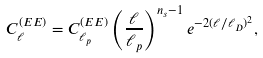Convert formula to latex. <formula><loc_0><loc_0><loc_500><loc_500>C _ { \ell } ^ { ( E E ) } = C _ { \ell _ { p } } ^ { ( E E ) } \left ( \frac { \ell } { \ell _ { p } } \right ) ^ { n _ { s } - 1 } e ^ { - 2 ( \ell / \ell _ { D } ) ^ { 2 } } ,</formula> 